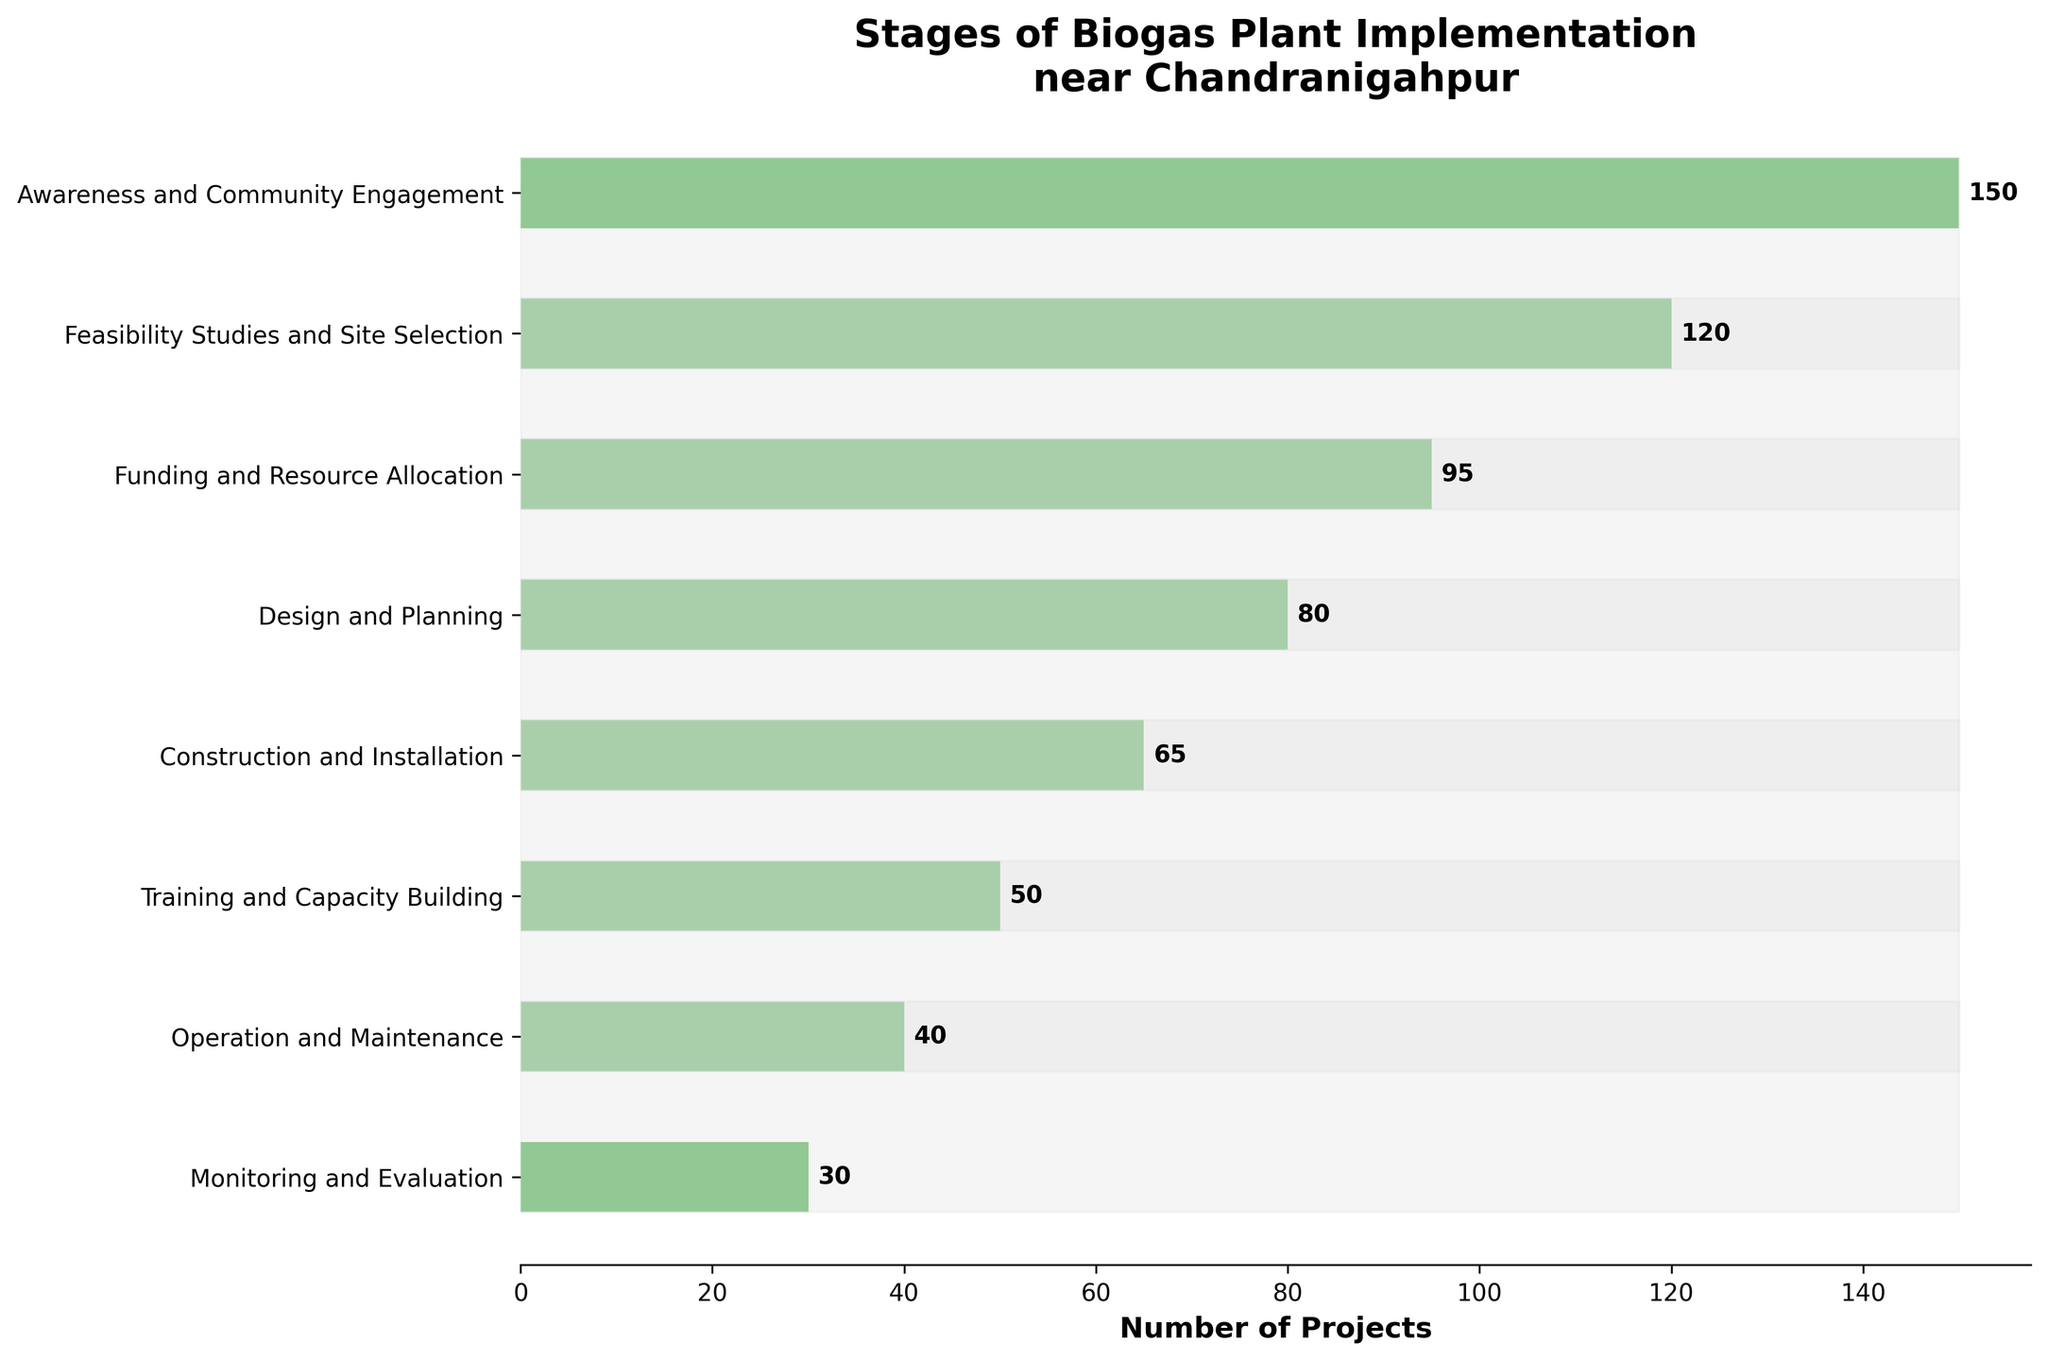What is the title of the figure? The title of the figure can be read directly at the top of the chart. It helps set the context for the visualized data.
Answer: Stages of Biogas Plant Implementation near Chandranigahpur Which stage has the highest number of projects? By identifying the widest bar at the top, we can see which stage has the highest number.
Answer: Awareness and Community Engagement How many projects reached the Training and Capacity Building stage? Locate the bar labeled "Training and Capacity Building" and read its numerical value.
Answer: 50 What is the difference in the number of projects between Feasibility Studies and Site Selection and Design and Planning? Subtract the number associated with Design and Planning from the number associated with Feasibility Studies and Site Selection.
Answer: 120 - 80 = 40 Which stages have fewer than 50 projects? Identify and list the stages where the bar has a value less than 50.
Answer: Operation and Maintenance, Monitoring and Evaluation By how much does the number of projects decrease from Construction and Installation to Operation and Maintenance? Subtract the number of projects in Operation and Maintenance from those in Construction and Installation.
Answer: 65 - 40 = 25 Which stage has more projects: Funding and Resource Allocation or Training and Capacity Building? Compare the lengths of the bars for "Funding and Resource Allocation" and "Training and Capacity Building".
Answer: Funding and Resource Allocation What is the total number of projects across all stages? Sum all the provided numerical values for each stage.
Answer: 150 + 120 + 95 + 80 + 65 + 50 + 40 + 30 = 630 At which stage do the number of projects fall below half of those in the Awareness and Community Engagement stage? Calculate half of the projects in the Awareness and Community Engagement stage and identify the stages with values below this number.
Answer: Design and Planning (or any stage past it) What can be inferred about the trend in the number of projects as the stages progress? Observe the overall direction of the bars from top to bottom to describe the trend.
Answer: Decreasing trend 